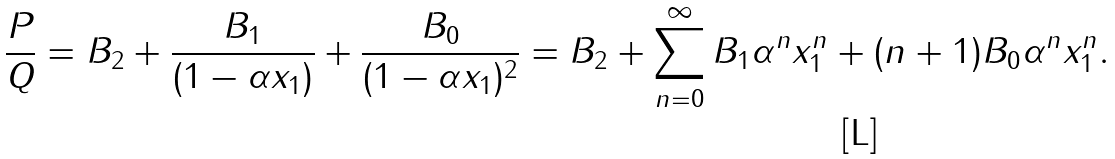Convert formula to latex. <formula><loc_0><loc_0><loc_500><loc_500>\frac { P } { Q } = B _ { 2 } + \frac { B _ { 1 } } { ( 1 - \alpha x _ { 1 } ) } + \frac { B _ { 0 } } { ( 1 - \alpha x _ { 1 } ) ^ { 2 } } = B _ { 2 } + \sum _ { n = 0 } ^ { \infty } B _ { 1 } \alpha ^ { n } x _ { 1 } ^ { n } + ( n + 1 ) B _ { 0 } \alpha ^ { n } x _ { 1 } ^ { n } .</formula> 